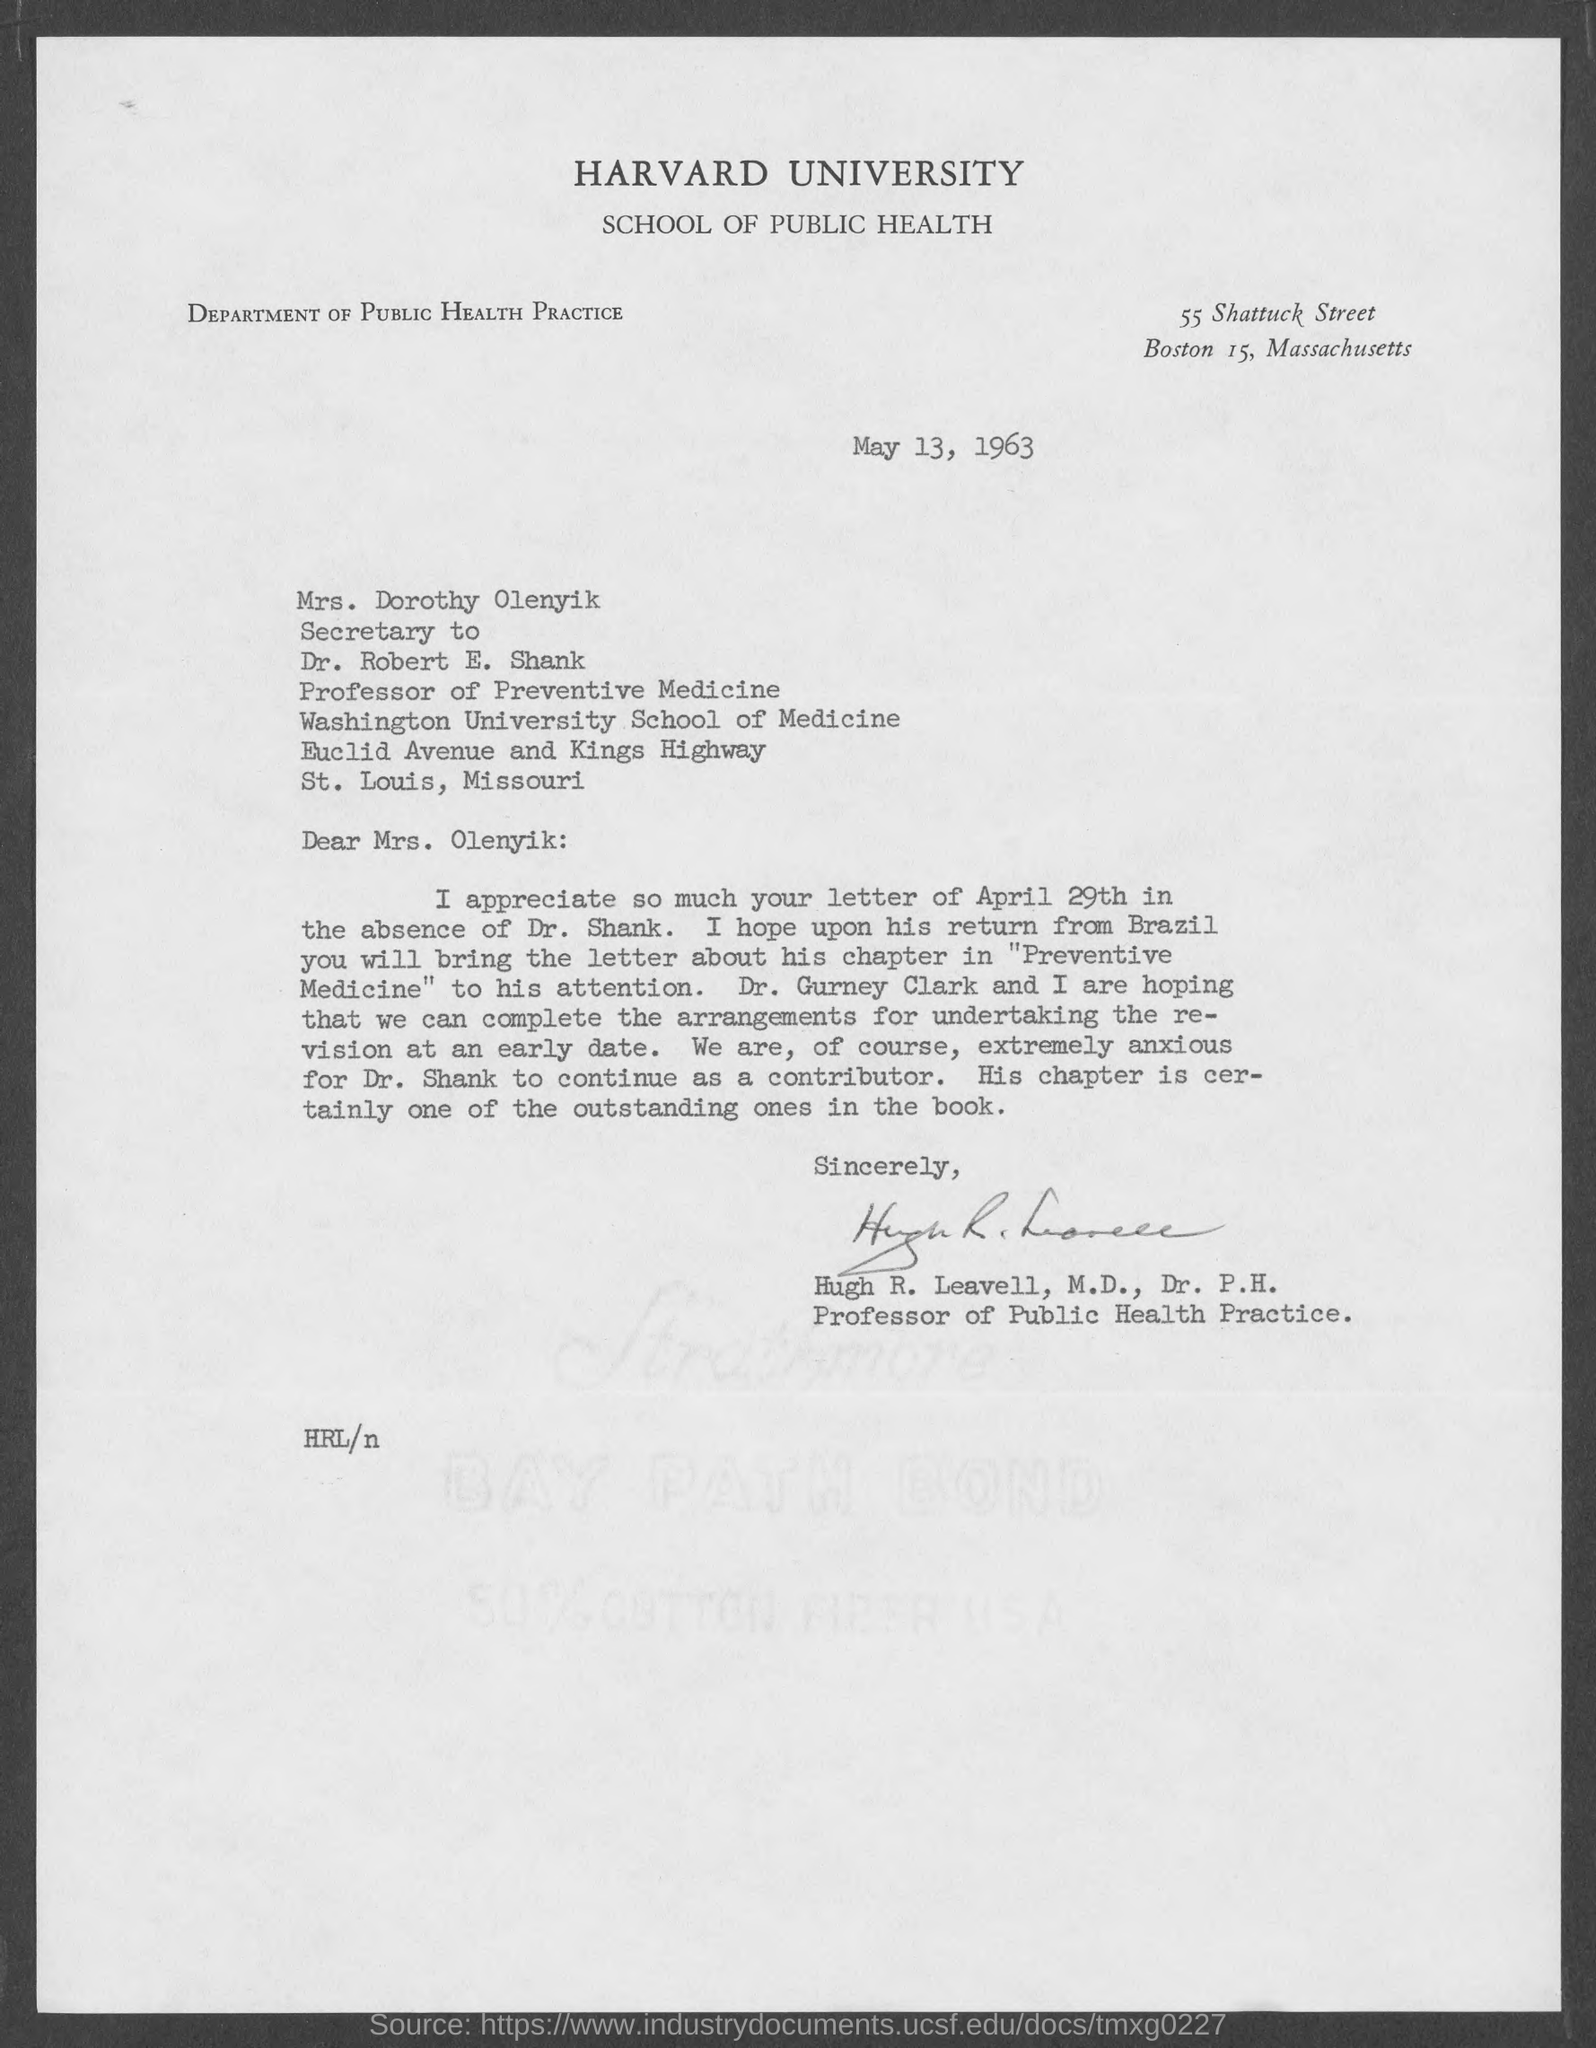Highlight a few significant elements in this photo. The secretary of Dr. Robert E. Shank is Mrs. Dorothy Olenyik. Hugh R. Leavell, M.D., Dr. P.H., wrote this letter. 